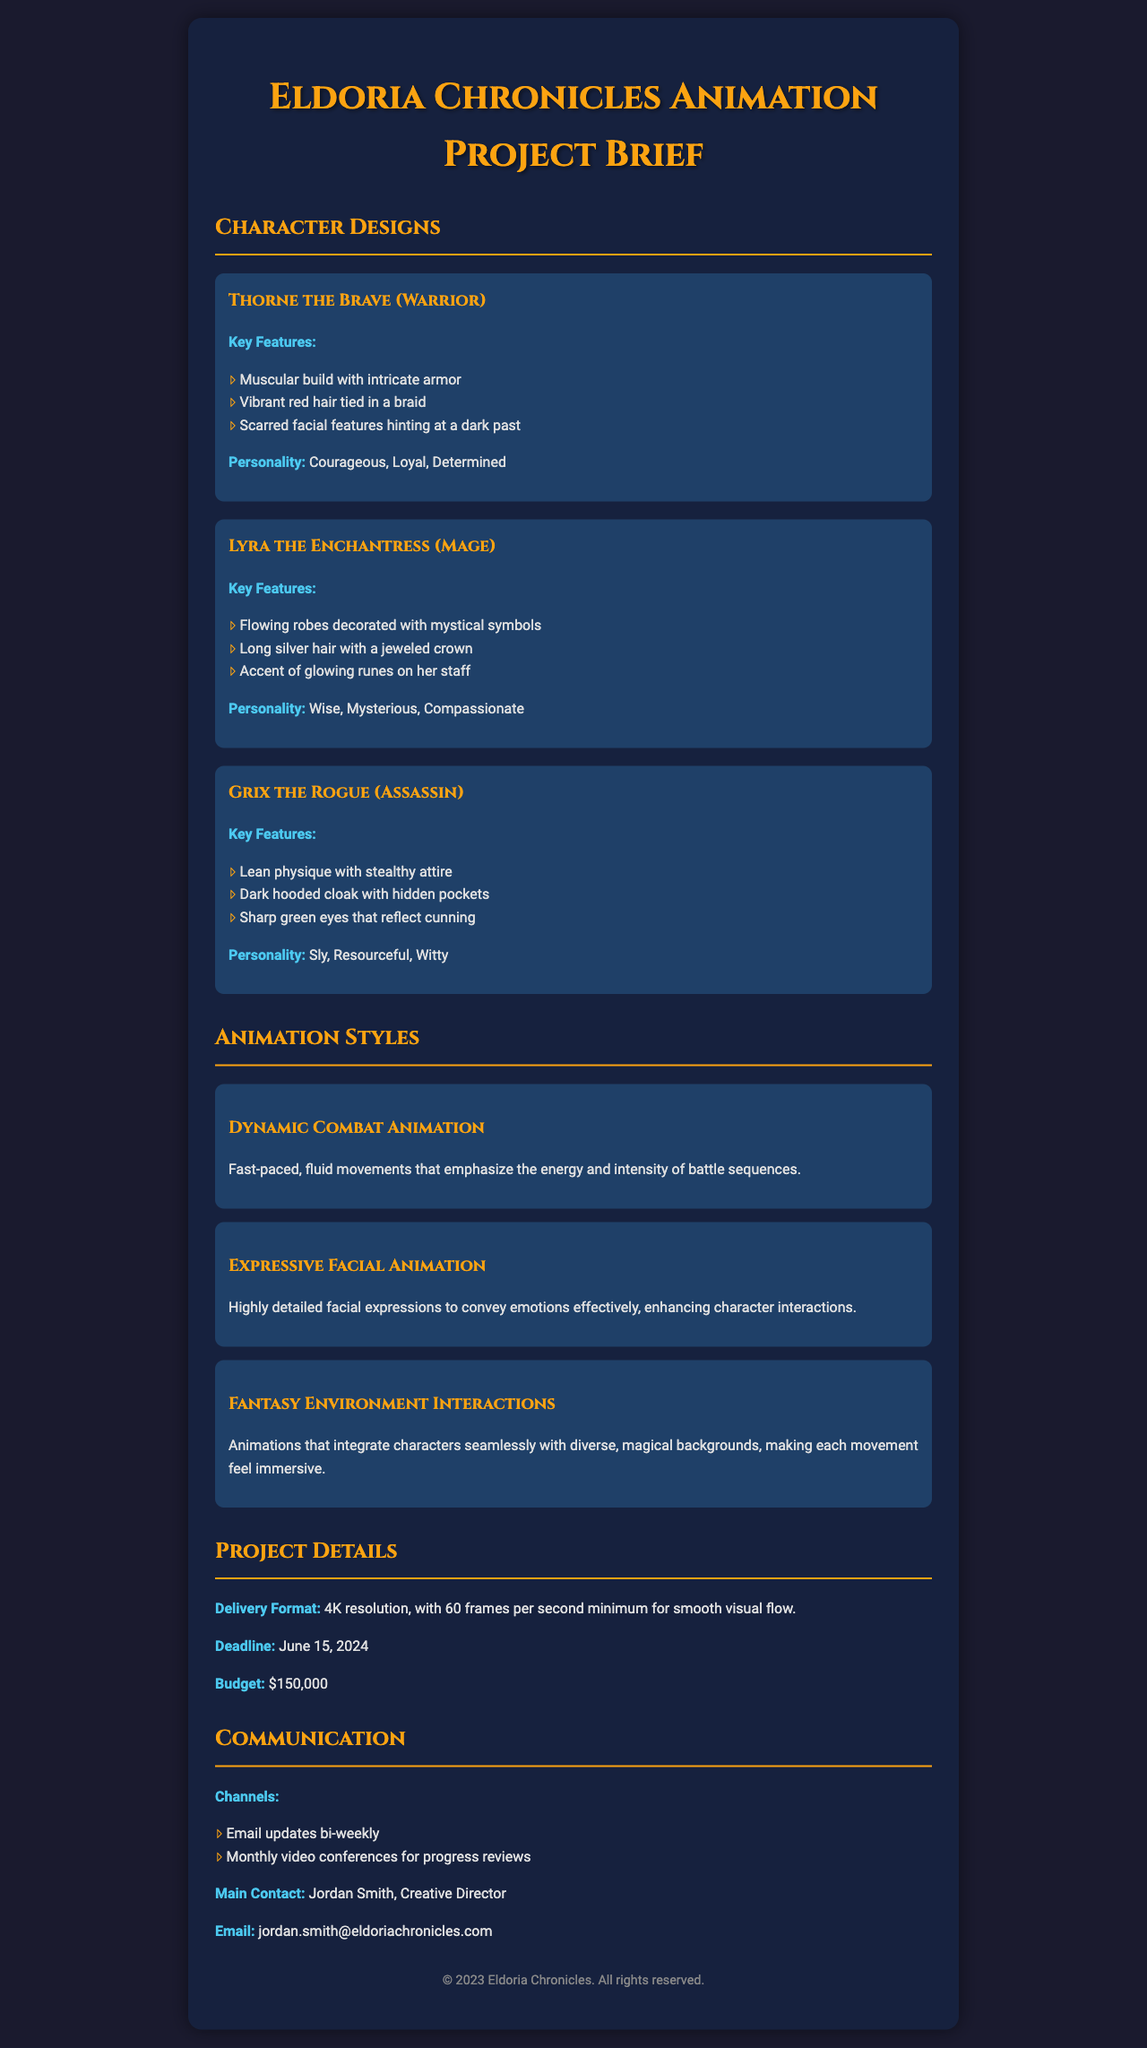What is the title of the project? The title of the project is prominently displayed at the top of the document.
Answer: Eldoria Chronicles Animation Project Brief Who is the creative director for this project? The document specifies the main contact person who is in charge of the creative aspects of the project.
Answer: Jordan Smith What is the budget allocated for the animation project? The budget is mentioned specifically within the project details section.
Answer: $150,000 What is the deadline for the project? The document states the deadline explicitly in the project details section.
Answer: June 15, 2024 What character is described as having a muscular build with intricate armor? The document categorizes characters and provides unique descriptions, including their physical traits.
Answer: Thorne the Brave How many animation styles are listed in the document? By reviewing the animation styles section, the count of distinct styles can be determined.
Answer: 3 Which character has long silver hair with a jeweled crown? The document gives detailed descriptions of character features allowing identification based on appearance.
Answer: Lyra the Enchantress What type of animation emphasizes fast-paced, fluid movements? The styles of animation are outlined with specific focuses in the document, referring to types of character movements.
Answer: Dynamic Combat Animation What channel is used for bi-weekly updates? The communication section specifies the frequency and method of updates between parties involved.
Answer: Email updates bi-weekly 